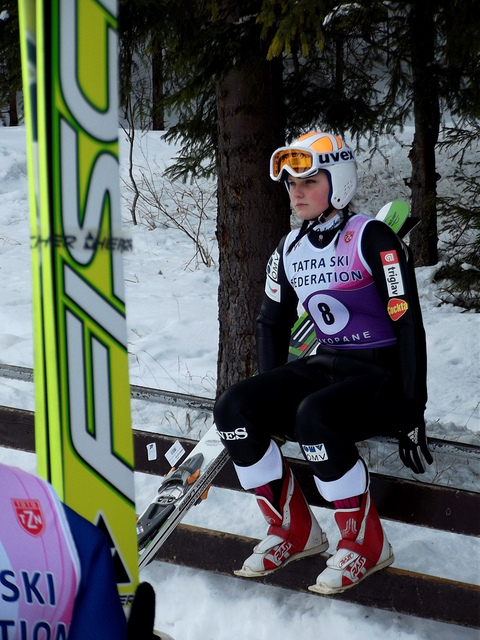Identify the text contained in this image. TATRA EDERATION SKI triglav 8 FISC uvex SKI TZN 